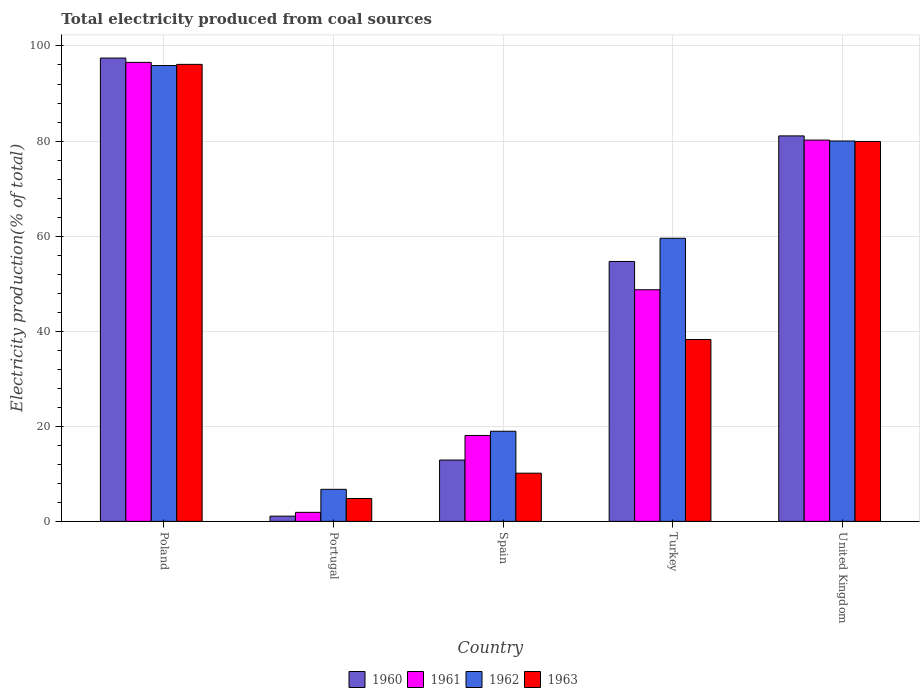What is the total electricity produced in 1960 in Poland?
Offer a terse response. 97.46. Across all countries, what is the maximum total electricity produced in 1963?
Provide a short and direct response. 96.13. Across all countries, what is the minimum total electricity produced in 1962?
Provide a short and direct response. 6.74. In which country was the total electricity produced in 1963 minimum?
Provide a succinct answer. Portugal. What is the total total electricity produced in 1962 in the graph?
Your answer should be very brief. 261.15. What is the difference between the total electricity produced in 1962 in Spain and that in United Kingdom?
Give a very brief answer. -61.06. What is the difference between the total electricity produced in 1960 in Turkey and the total electricity produced in 1963 in Portugal?
Your answer should be compact. 49.86. What is the average total electricity produced in 1961 per country?
Provide a succinct answer. 49.09. What is the difference between the total electricity produced of/in 1961 and total electricity produced of/in 1963 in Portugal?
Your answer should be compact. -2.91. What is the ratio of the total electricity produced in 1962 in Poland to that in Portugal?
Give a very brief answer. 14.23. Is the total electricity produced in 1963 in Poland less than that in United Kingdom?
Make the answer very short. No. What is the difference between the highest and the second highest total electricity produced in 1961?
Your answer should be very brief. 47.84. What is the difference between the highest and the lowest total electricity produced in 1962?
Your response must be concise. 89.15. In how many countries, is the total electricity produced in 1960 greater than the average total electricity produced in 1960 taken over all countries?
Give a very brief answer. 3. Is the sum of the total electricity produced in 1961 in Spain and Turkey greater than the maximum total electricity produced in 1963 across all countries?
Make the answer very short. No. Is it the case that in every country, the sum of the total electricity produced in 1961 and total electricity produced in 1962 is greater than the total electricity produced in 1960?
Make the answer very short. Yes. Are all the bars in the graph horizontal?
Your response must be concise. No. Are the values on the major ticks of Y-axis written in scientific E-notation?
Offer a terse response. No. Does the graph contain grids?
Give a very brief answer. Yes. How many legend labels are there?
Your answer should be very brief. 4. What is the title of the graph?
Your answer should be very brief. Total electricity produced from coal sources. Does "1970" appear as one of the legend labels in the graph?
Provide a short and direct response. No. What is the Electricity production(% of total) in 1960 in Poland?
Offer a terse response. 97.46. What is the Electricity production(% of total) of 1961 in Poland?
Ensure brevity in your answer.  96.56. What is the Electricity production(% of total) of 1962 in Poland?
Provide a succinct answer. 95.89. What is the Electricity production(% of total) in 1963 in Poland?
Your answer should be compact. 96.13. What is the Electricity production(% of total) in 1960 in Portugal?
Your answer should be very brief. 1.1. What is the Electricity production(% of total) of 1961 in Portugal?
Your answer should be compact. 1.89. What is the Electricity production(% of total) of 1962 in Portugal?
Provide a short and direct response. 6.74. What is the Electricity production(% of total) in 1963 in Portugal?
Give a very brief answer. 4.81. What is the Electricity production(% of total) of 1960 in Spain?
Ensure brevity in your answer.  12.9. What is the Electricity production(% of total) in 1961 in Spain?
Make the answer very short. 18.07. What is the Electricity production(% of total) of 1962 in Spain?
Provide a short and direct response. 18.96. What is the Electricity production(% of total) of 1963 in Spain?
Provide a short and direct response. 10.14. What is the Electricity production(% of total) in 1960 in Turkey?
Give a very brief answer. 54.67. What is the Electricity production(% of total) of 1961 in Turkey?
Offer a terse response. 48.72. What is the Electricity production(% of total) of 1962 in Turkey?
Offer a terse response. 59.55. What is the Electricity production(% of total) of 1963 in Turkey?
Provide a succinct answer. 38.26. What is the Electricity production(% of total) of 1960 in United Kingdom?
Ensure brevity in your answer.  81.09. What is the Electricity production(% of total) of 1961 in United Kingdom?
Make the answer very short. 80.21. What is the Electricity production(% of total) of 1962 in United Kingdom?
Offer a very short reply. 80.01. What is the Electricity production(% of total) in 1963 in United Kingdom?
Provide a succinct answer. 79.91. Across all countries, what is the maximum Electricity production(% of total) of 1960?
Give a very brief answer. 97.46. Across all countries, what is the maximum Electricity production(% of total) in 1961?
Your answer should be compact. 96.56. Across all countries, what is the maximum Electricity production(% of total) of 1962?
Offer a very short reply. 95.89. Across all countries, what is the maximum Electricity production(% of total) in 1963?
Provide a succinct answer. 96.13. Across all countries, what is the minimum Electricity production(% of total) of 1960?
Offer a very short reply. 1.1. Across all countries, what is the minimum Electricity production(% of total) of 1961?
Offer a terse response. 1.89. Across all countries, what is the minimum Electricity production(% of total) in 1962?
Make the answer very short. 6.74. Across all countries, what is the minimum Electricity production(% of total) of 1963?
Your answer should be very brief. 4.81. What is the total Electricity production(% of total) in 1960 in the graph?
Your answer should be very brief. 247.22. What is the total Electricity production(% of total) of 1961 in the graph?
Your response must be concise. 245.45. What is the total Electricity production(% of total) of 1962 in the graph?
Provide a succinct answer. 261.15. What is the total Electricity production(% of total) of 1963 in the graph?
Offer a very short reply. 229.25. What is the difference between the Electricity production(% of total) in 1960 in Poland and that in Portugal?
Make the answer very short. 96.36. What is the difference between the Electricity production(% of total) in 1961 in Poland and that in Portugal?
Your answer should be very brief. 94.66. What is the difference between the Electricity production(% of total) of 1962 in Poland and that in Portugal?
Offer a terse response. 89.15. What is the difference between the Electricity production(% of total) in 1963 in Poland and that in Portugal?
Provide a short and direct response. 91.32. What is the difference between the Electricity production(% of total) in 1960 in Poland and that in Spain?
Offer a very short reply. 84.56. What is the difference between the Electricity production(% of total) of 1961 in Poland and that in Spain?
Your answer should be very brief. 78.49. What is the difference between the Electricity production(% of total) of 1962 in Poland and that in Spain?
Make the answer very short. 76.93. What is the difference between the Electricity production(% of total) in 1963 in Poland and that in Spain?
Keep it short and to the point. 86. What is the difference between the Electricity production(% of total) of 1960 in Poland and that in Turkey?
Provide a short and direct response. 42.79. What is the difference between the Electricity production(% of total) in 1961 in Poland and that in Turkey?
Give a very brief answer. 47.84. What is the difference between the Electricity production(% of total) of 1962 in Poland and that in Turkey?
Provide a succinct answer. 36.34. What is the difference between the Electricity production(% of total) in 1963 in Poland and that in Turkey?
Provide a succinct answer. 57.87. What is the difference between the Electricity production(% of total) in 1960 in Poland and that in United Kingdom?
Keep it short and to the point. 16.38. What is the difference between the Electricity production(% of total) of 1961 in Poland and that in United Kingdom?
Keep it short and to the point. 16.35. What is the difference between the Electricity production(% of total) in 1962 in Poland and that in United Kingdom?
Your response must be concise. 15.87. What is the difference between the Electricity production(% of total) in 1963 in Poland and that in United Kingdom?
Ensure brevity in your answer.  16.22. What is the difference between the Electricity production(% of total) of 1960 in Portugal and that in Spain?
Keep it short and to the point. -11.8. What is the difference between the Electricity production(% of total) in 1961 in Portugal and that in Spain?
Provide a short and direct response. -16.18. What is the difference between the Electricity production(% of total) of 1962 in Portugal and that in Spain?
Provide a succinct answer. -12.22. What is the difference between the Electricity production(% of total) in 1963 in Portugal and that in Spain?
Your answer should be very brief. -5.33. What is the difference between the Electricity production(% of total) of 1960 in Portugal and that in Turkey?
Provide a short and direct response. -53.57. What is the difference between the Electricity production(% of total) of 1961 in Portugal and that in Turkey?
Your answer should be compact. -46.83. What is the difference between the Electricity production(% of total) in 1962 in Portugal and that in Turkey?
Give a very brief answer. -52.81. What is the difference between the Electricity production(% of total) of 1963 in Portugal and that in Turkey?
Your answer should be very brief. -33.45. What is the difference between the Electricity production(% of total) in 1960 in Portugal and that in United Kingdom?
Make the answer very short. -79.99. What is the difference between the Electricity production(% of total) in 1961 in Portugal and that in United Kingdom?
Your answer should be very brief. -78.31. What is the difference between the Electricity production(% of total) in 1962 in Portugal and that in United Kingdom?
Your answer should be compact. -73.27. What is the difference between the Electricity production(% of total) in 1963 in Portugal and that in United Kingdom?
Make the answer very short. -75.1. What is the difference between the Electricity production(% of total) of 1960 in Spain and that in Turkey?
Your answer should be very brief. -41.77. What is the difference between the Electricity production(% of total) in 1961 in Spain and that in Turkey?
Keep it short and to the point. -30.65. What is the difference between the Electricity production(% of total) in 1962 in Spain and that in Turkey?
Offer a very short reply. -40.59. What is the difference between the Electricity production(% of total) of 1963 in Spain and that in Turkey?
Keep it short and to the point. -28.13. What is the difference between the Electricity production(% of total) in 1960 in Spain and that in United Kingdom?
Provide a succinct answer. -68.19. What is the difference between the Electricity production(% of total) in 1961 in Spain and that in United Kingdom?
Your answer should be very brief. -62.14. What is the difference between the Electricity production(% of total) in 1962 in Spain and that in United Kingdom?
Your answer should be very brief. -61.06. What is the difference between the Electricity production(% of total) in 1963 in Spain and that in United Kingdom?
Your answer should be compact. -69.78. What is the difference between the Electricity production(% of total) in 1960 in Turkey and that in United Kingdom?
Provide a succinct answer. -26.41. What is the difference between the Electricity production(% of total) of 1961 in Turkey and that in United Kingdom?
Provide a short and direct response. -31.49. What is the difference between the Electricity production(% of total) of 1962 in Turkey and that in United Kingdom?
Offer a very short reply. -20.46. What is the difference between the Electricity production(% of total) in 1963 in Turkey and that in United Kingdom?
Your answer should be very brief. -41.65. What is the difference between the Electricity production(% of total) of 1960 in Poland and the Electricity production(% of total) of 1961 in Portugal?
Keep it short and to the point. 95.57. What is the difference between the Electricity production(% of total) of 1960 in Poland and the Electricity production(% of total) of 1962 in Portugal?
Offer a terse response. 90.72. What is the difference between the Electricity production(% of total) in 1960 in Poland and the Electricity production(% of total) in 1963 in Portugal?
Keep it short and to the point. 92.65. What is the difference between the Electricity production(% of total) in 1961 in Poland and the Electricity production(% of total) in 1962 in Portugal?
Your answer should be very brief. 89.82. What is the difference between the Electricity production(% of total) of 1961 in Poland and the Electricity production(% of total) of 1963 in Portugal?
Your answer should be compact. 91.75. What is the difference between the Electricity production(% of total) in 1962 in Poland and the Electricity production(% of total) in 1963 in Portugal?
Provide a short and direct response. 91.08. What is the difference between the Electricity production(% of total) of 1960 in Poland and the Electricity production(% of total) of 1961 in Spain?
Provide a succinct answer. 79.39. What is the difference between the Electricity production(% of total) in 1960 in Poland and the Electricity production(% of total) in 1962 in Spain?
Your answer should be compact. 78.51. What is the difference between the Electricity production(% of total) in 1960 in Poland and the Electricity production(% of total) in 1963 in Spain?
Provide a short and direct response. 87.33. What is the difference between the Electricity production(% of total) in 1961 in Poland and the Electricity production(% of total) in 1962 in Spain?
Offer a terse response. 77.6. What is the difference between the Electricity production(% of total) of 1961 in Poland and the Electricity production(% of total) of 1963 in Spain?
Keep it short and to the point. 86.42. What is the difference between the Electricity production(% of total) in 1962 in Poland and the Electricity production(% of total) in 1963 in Spain?
Provide a short and direct response. 85.75. What is the difference between the Electricity production(% of total) of 1960 in Poland and the Electricity production(% of total) of 1961 in Turkey?
Your response must be concise. 48.74. What is the difference between the Electricity production(% of total) of 1960 in Poland and the Electricity production(% of total) of 1962 in Turkey?
Your answer should be compact. 37.91. What is the difference between the Electricity production(% of total) of 1960 in Poland and the Electricity production(% of total) of 1963 in Turkey?
Ensure brevity in your answer.  59.2. What is the difference between the Electricity production(% of total) in 1961 in Poland and the Electricity production(% of total) in 1962 in Turkey?
Ensure brevity in your answer.  37.01. What is the difference between the Electricity production(% of total) in 1961 in Poland and the Electricity production(% of total) in 1963 in Turkey?
Give a very brief answer. 58.29. What is the difference between the Electricity production(% of total) of 1962 in Poland and the Electricity production(% of total) of 1963 in Turkey?
Make the answer very short. 57.63. What is the difference between the Electricity production(% of total) of 1960 in Poland and the Electricity production(% of total) of 1961 in United Kingdom?
Your answer should be compact. 17.26. What is the difference between the Electricity production(% of total) in 1960 in Poland and the Electricity production(% of total) in 1962 in United Kingdom?
Give a very brief answer. 17.45. What is the difference between the Electricity production(% of total) of 1960 in Poland and the Electricity production(% of total) of 1963 in United Kingdom?
Your answer should be compact. 17.55. What is the difference between the Electricity production(% of total) in 1961 in Poland and the Electricity production(% of total) in 1962 in United Kingdom?
Your response must be concise. 16.54. What is the difference between the Electricity production(% of total) in 1961 in Poland and the Electricity production(% of total) in 1963 in United Kingdom?
Offer a very short reply. 16.64. What is the difference between the Electricity production(% of total) in 1962 in Poland and the Electricity production(% of total) in 1963 in United Kingdom?
Offer a very short reply. 15.97. What is the difference between the Electricity production(% of total) in 1960 in Portugal and the Electricity production(% of total) in 1961 in Spain?
Offer a terse response. -16.97. What is the difference between the Electricity production(% of total) in 1960 in Portugal and the Electricity production(% of total) in 1962 in Spain?
Your answer should be compact. -17.86. What is the difference between the Electricity production(% of total) of 1960 in Portugal and the Electricity production(% of total) of 1963 in Spain?
Make the answer very short. -9.04. What is the difference between the Electricity production(% of total) in 1961 in Portugal and the Electricity production(% of total) in 1962 in Spain?
Keep it short and to the point. -17.06. What is the difference between the Electricity production(% of total) of 1961 in Portugal and the Electricity production(% of total) of 1963 in Spain?
Provide a short and direct response. -8.24. What is the difference between the Electricity production(% of total) in 1962 in Portugal and the Electricity production(% of total) in 1963 in Spain?
Ensure brevity in your answer.  -3.4. What is the difference between the Electricity production(% of total) of 1960 in Portugal and the Electricity production(% of total) of 1961 in Turkey?
Ensure brevity in your answer.  -47.62. What is the difference between the Electricity production(% of total) of 1960 in Portugal and the Electricity production(% of total) of 1962 in Turkey?
Provide a short and direct response. -58.45. What is the difference between the Electricity production(% of total) of 1960 in Portugal and the Electricity production(% of total) of 1963 in Turkey?
Provide a short and direct response. -37.16. What is the difference between the Electricity production(% of total) of 1961 in Portugal and the Electricity production(% of total) of 1962 in Turkey?
Your answer should be very brief. -57.66. What is the difference between the Electricity production(% of total) of 1961 in Portugal and the Electricity production(% of total) of 1963 in Turkey?
Make the answer very short. -36.37. What is the difference between the Electricity production(% of total) of 1962 in Portugal and the Electricity production(% of total) of 1963 in Turkey?
Ensure brevity in your answer.  -31.52. What is the difference between the Electricity production(% of total) in 1960 in Portugal and the Electricity production(% of total) in 1961 in United Kingdom?
Ensure brevity in your answer.  -79.11. What is the difference between the Electricity production(% of total) in 1960 in Portugal and the Electricity production(% of total) in 1962 in United Kingdom?
Keep it short and to the point. -78.92. What is the difference between the Electricity production(% of total) in 1960 in Portugal and the Electricity production(% of total) in 1963 in United Kingdom?
Your answer should be compact. -78.82. What is the difference between the Electricity production(% of total) of 1961 in Portugal and the Electricity production(% of total) of 1962 in United Kingdom?
Provide a succinct answer. -78.12. What is the difference between the Electricity production(% of total) in 1961 in Portugal and the Electricity production(% of total) in 1963 in United Kingdom?
Provide a succinct answer. -78.02. What is the difference between the Electricity production(% of total) in 1962 in Portugal and the Electricity production(% of total) in 1963 in United Kingdom?
Ensure brevity in your answer.  -73.17. What is the difference between the Electricity production(% of total) in 1960 in Spain and the Electricity production(% of total) in 1961 in Turkey?
Your answer should be compact. -35.82. What is the difference between the Electricity production(% of total) in 1960 in Spain and the Electricity production(% of total) in 1962 in Turkey?
Keep it short and to the point. -46.65. What is the difference between the Electricity production(% of total) of 1960 in Spain and the Electricity production(% of total) of 1963 in Turkey?
Offer a terse response. -25.36. What is the difference between the Electricity production(% of total) in 1961 in Spain and the Electricity production(% of total) in 1962 in Turkey?
Provide a short and direct response. -41.48. What is the difference between the Electricity production(% of total) of 1961 in Spain and the Electricity production(% of total) of 1963 in Turkey?
Your answer should be very brief. -20.19. What is the difference between the Electricity production(% of total) in 1962 in Spain and the Electricity production(% of total) in 1963 in Turkey?
Offer a terse response. -19.31. What is the difference between the Electricity production(% of total) of 1960 in Spain and the Electricity production(% of total) of 1961 in United Kingdom?
Give a very brief answer. -67.31. What is the difference between the Electricity production(% of total) in 1960 in Spain and the Electricity production(% of total) in 1962 in United Kingdom?
Your answer should be compact. -67.12. What is the difference between the Electricity production(% of total) of 1960 in Spain and the Electricity production(% of total) of 1963 in United Kingdom?
Ensure brevity in your answer.  -67.02. What is the difference between the Electricity production(% of total) in 1961 in Spain and the Electricity production(% of total) in 1962 in United Kingdom?
Your response must be concise. -61.94. What is the difference between the Electricity production(% of total) in 1961 in Spain and the Electricity production(% of total) in 1963 in United Kingdom?
Your answer should be compact. -61.84. What is the difference between the Electricity production(% of total) of 1962 in Spain and the Electricity production(% of total) of 1963 in United Kingdom?
Make the answer very short. -60.96. What is the difference between the Electricity production(% of total) in 1960 in Turkey and the Electricity production(% of total) in 1961 in United Kingdom?
Your answer should be very brief. -25.54. What is the difference between the Electricity production(% of total) of 1960 in Turkey and the Electricity production(% of total) of 1962 in United Kingdom?
Make the answer very short. -25.34. What is the difference between the Electricity production(% of total) of 1960 in Turkey and the Electricity production(% of total) of 1963 in United Kingdom?
Keep it short and to the point. -25.24. What is the difference between the Electricity production(% of total) in 1961 in Turkey and the Electricity production(% of total) in 1962 in United Kingdom?
Your response must be concise. -31.29. What is the difference between the Electricity production(% of total) of 1961 in Turkey and the Electricity production(% of total) of 1963 in United Kingdom?
Make the answer very short. -31.19. What is the difference between the Electricity production(% of total) in 1962 in Turkey and the Electricity production(% of total) in 1963 in United Kingdom?
Your answer should be very brief. -20.36. What is the average Electricity production(% of total) in 1960 per country?
Provide a short and direct response. 49.44. What is the average Electricity production(% of total) in 1961 per country?
Your answer should be compact. 49.09. What is the average Electricity production(% of total) in 1962 per country?
Your answer should be compact. 52.23. What is the average Electricity production(% of total) in 1963 per country?
Your response must be concise. 45.85. What is the difference between the Electricity production(% of total) in 1960 and Electricity production(% of total) in 1961 in Poland?
Provide a succinct answer. 0.91. What is the difference between the Electricity production(% of total) in 1960 and Electricity production(% of total) in 1962 in Poland?
Your answer should be very brief. 1.57. What is the difference between the Electricity production(% of total) of 1960 and Electricity production(% of total) of 1963 in Poland?
Provide a short and direct response. 1.33. What is the difference between the Electricity production(% of total) in 1961 and Electricity production(% of total) in 1962 in Poland?
Keep it short and to the point. 0.67. What is the difference between the Electricity production(% of total) of 1961 and Electricity production(% of total) of 1963 in Poland?
Your answer should be compact. 0.43. What is the difference between the Electricity production(% of total) in 1962 and Electricity production(% of total) in 1963 in Poland?
Give a very brief answer. -0.24. What is the difference between the Electricity production(% of total) of 1960 and Electricity production(% of total) of 1961 in Portugal?
Your answer should be very brief. -0.8. What is the difference between the Electricity production(% of total) of 1960 and Electricity production(% of total) of 1962 in Portugal?
Provide a succinct answer. -5.64. What is the difference between the Electricity production(% of total) of 1960 and Electricity production(% of total) of 1963 in Portugal?
Offer a very short reply. -3.71. What is the difference between the Electricity production(% of total) in 1961 and Electricity production(% of total) in 1962 in Portugal?
Offer a terse response. -4.85. What is the difference between the Electricity production(% of total) in 1961 and Electricity production(% of total) in 1963 in Portugal?
Your answer should be compact. -2.91. What is the difference between the Electricity production(% of total) in 1962 and Electricity production(% of total) in 1963 in Portugal?
Offer a very short reply. 1.93. What is the difference between the Electricity production(% of total) of 1960 and Electricity production(% of total) of 1961 in Spain?
Make the answer very short. -5.17. What is the difference between the Electricity production(% of total) of 1960 and Electricity production(% of total) of 1962 in Spain?
Your response must be concise. -6.06. What is the difference between the Electricity production(% of total) of 1960 and Electricity production(% of total) of 1963 in Spain?
Keep it short and to the point. 2.76. What is the difference between the Electricity production(% of total) of 1961 and Electricity production(% of total) of 1962 in Spain?
Give a very brief answer. -0.88. What is the difference between the Electricity production(% of total) of 1961 and Electricity production(% of total) of 1963 in Spain?
Ensure brevity in your answer.  7.94. What is the difference between the Electricity production(% of total) of 1962 and Electricity production(% of total) of 1963 in Spain?
Your answer should be compact. 8.82. What is the difference between the Electricity production(% of total) in 1960 and Electricity production(% of total) in 1961 in Turkey?
Your response must be concise. 5.95. What is the difference between the Electricity production(% of total) of 1960 and Electricity production(% of total) of 1962 in Turkey?
Your answer should be very brief. -4.88. What is the difference between the Electricity production(% of total) in 1960 and Electricity production(% of total) in 1963 in Turkey?
Offer a very short reply. 16.41. What is the difference between the Electricity production(% of total) in 1961 and Electricity production(% of total) in 1962 in Turkey?
Give a very brief answer. -10.83. What is the difference between the Electricity production(% of total) in 1961 and Electricity production(% of total) in 1963 in Turkey?
Your answer should be very brief. 10.46. What is the difference between the Electricity production(% of total) in 1962 and Electricity production(% of total) in 1963 in Turkey?
Keep it short and to the point. 21.29. What is the difference between the Electricity production(% of total) of 1960 and Electricity production(% of total) of 1961 in United Kingdom?
Provide a succinct answer. 0.88. What is the difference between the Electricity production(% of total) of 1960 and Electricity production(% of total) of 1962 in United Kingdom?
Provide a short and direct response. 1.07. What is the difference between the Electricity production(% of total) of 1960 and Electricity production(% of total) of 1963 in United Kingdom?
Ensure brevity in your answer.  1.17. What is the difference between the Electricity production(% of total) in 1961 and Electricity production(% of total) in 1962 in United Kingdom?
Offer a terse response. 0.19. What is the difference between the Electricity production(% of total) in 1961 and Electricity production(% of total) in 1963 in United Kingdom?
Keep it short and to the point. 0.29. What is the difference between the Electricity production(% of total) of 1962 and Electricity production(% of total) of 1963 in United Kingdom?
Offer a terse response. 0.1. What is the ratio of the Electricity production(% of total) of 1960 in Poland to that in Portugal?
Make the answer very short. 88.77. What is the ratio of the Electricity production(% of total) in 1961 in Poland to that in Portugal?
Ensure brevity in your answer.  50.97. What is the ratio of the Electricity production(% of total) in 1962 in Poland to that in Portugal?
Your response must be concise. 14.23. What is the ratio of the Electricity production(% of total) in 1963 in Poland to that in Portugal?
Make the answer very short. 19.99. What is the ratio of the Electricity production(% of total) of 1960 in Poland to that in Spain?
Ensure brevity in your answer.  7.56. What is the ratio of the Electricity production(% of total) of 1961 in Poland to that in Spain?
Your response must be concise. 5.34. What is the ratio of the Electricity production(% of total) in 1962 in Poland to that in Spain?
Ensure brevity in your answer.  5.06. What is the ratio of the Electricity production(% of total) of 1963 in Poland to that in Spain?
Give a very brief answer. 9.48. What is the ratio of the Electricity production(% of total) of 1960 in Poland to that in Turkey?
Ensure brevity in your answer.  1.78. What is the ratio of the Electricity production(% of total) in 1961 in Poland to that in Turkey?
Provide a short and direct response. 1.98. What is the ratio of the Electricity production(% of total) in 1962 in Poland to that in Turkey?
Offer a very short reply. 1.61. What is the ratio of the Electricity production(% of total) of 1963 in Poland to that in Turkey?
Keep it short and to the point. 2.51. What is the ratio of the Electricity production(% of total) in 1960 in Poland to that in United Kingdom?
Your answer should be very brief. 1.2. What is the ratio of the Electricity production(% of total) in 1961 in Poland to that in United Kingdom?
Your response must be concise. 1.2. What is the ratio of the Electricity production(% of total) of 1962 in Poland to that in United Kingdom?
Keep it short and to the point. 1.2. What is the ratio of the Electricity production(% of total) in 1963 in Poland to that in United Kingdom?
Provide a succinct answer. 1.2. What is the ratio of the Electricity production(% of total) of 1960 in Portugal to that in Spain?
Offer a very short reply. 0.09. What is the ratio of the Electricity production(% of total) of 1961 in Portugal to that in Spain?
Your answer should be very brief. 0.1. What is the ratio of the Electricity production(% of total) of 1962 in Portugal to that in Spain?
Offer a terse response. 0.36. What is the ratio of the Electricity production(% of total) in 1963 in Portugal to that in Spain?
Make the answer very short. 0.47. What is the ratio of the Electricity production(% of total) in 1960 in Portugal to that in Turkey?
Your response must be concise. 0.02. What is the ratio of the Electricity production(% of total) in 1961 in Portugal to that in Turkey?
Your answer should be very brief. 0.04. What is the ratio of the Electricity production(% of total) of 1962 in Portugal to that in Turkey?
Offer a terse response. 0.11. What is the ratio of the Electricity production(% of total) of 1963 in Portugal to that in Turkey?
Ensure brevity in your answer.  0.13. What is the ratio of the Electricity production(% of total) of 1960 in Portugal to that in United Kingdom?
Your answer should be compact. 0.01. What is the ratio of the Electricity production(% of total) in 1961 in Portugal to that in United Kingdom?
Provide a short and direct response. 0.02. What is the ratio of the Electricity production(% of total) of 1962 in Portugal to that in United Kingdom?
Offer a terse response. 0.08. What is the ratio of the Electricity production(% of total) of 1963 in Portugal to that in United Kingdom?
Provide a succinct answer. 0.06. What is the ratio of the Electricity production(% of total) in 1960 in Spain to that in Turkey?
Your answer should be compact. 0.24. What is the ratio of the Electricity production(% of total) in 1961 in Spain to that in Turkey?
Give a very brief answer. 0.37. What is the ratio of the Electricity production(% of total) of 1962 in Spain to that in Turkey?
Your answer should be very brief. 0.32. What is the ratio of the Electricity production(% of total) of 1963 in Spain to that in Turkey?
Give a very brief answer. 0.26. What is the ratio of the Electricity production(% of total) in 1960 in Spain to that in United Kingdom?
Make the answer very short. 0.16. What is the ratio of the Electricity production(% of total) of 1961 in Spain to that in United Kingdom?
Your answer should be compact. 0.23. What is the ratio of the Electricity production(% of total) in 1962 in Spain to that in United Kingdom?
Make the answer very short. 0.24. What is the ratio of the Electricity production(% of total) of 1963 in Spain to that in United Kingdom?
Provide a succinct answer. 0.13. What is the ratio of the Electricity production(% of total) in 1960 in Turkey to that in United Kingdom?
Offer a very short reply. 0.67. What is the ratio of the Electricity production(% of total) in 1961 in Turkey to that in United Kingdom?
Make the answer very short. 0.61. What is the ratio of the Electricity production(% of total) in 1962 in Turkey to that in United Kingdom?
Your response must be concise. 0.74. What is the ratio of the Electricity production(% of total) of 1963 in Turkey to that in United Kingdom?
Your response must be concise. 0.48. What is the difference between the highest and the second highest Electricity production(% of total) in 1960?
Your response must be concise. 16.38. What is the difference between the highest and the second highest Electricity production(% of total) of 1961?
Offer a terse response. 16.35. What is the difference between the highest and the second highest Electricity production(% of total) of 1962?
Ensure brevity in your answer.  15.87. What is the difference between the highest and the second highest Electricity production(% of total) of 1963?
Offer a very short reply. 16.22. What is the difference between the highest and the lowest Electricity production(% of total) of 1960?
Provide a succinct answer. 96.36. What is the difference between the highest and the lowest Electricity production(% of total) in 1961?
Make the answer very short. 94.66. What is the difference between the highest and the lowest Electricity production(% of total) of 1962?
Your answer should be compact. 89.15. What is the difference between the highest and the lowest Electricity production(% of total) of 1963?
Offer a very short reply. 91.32. 